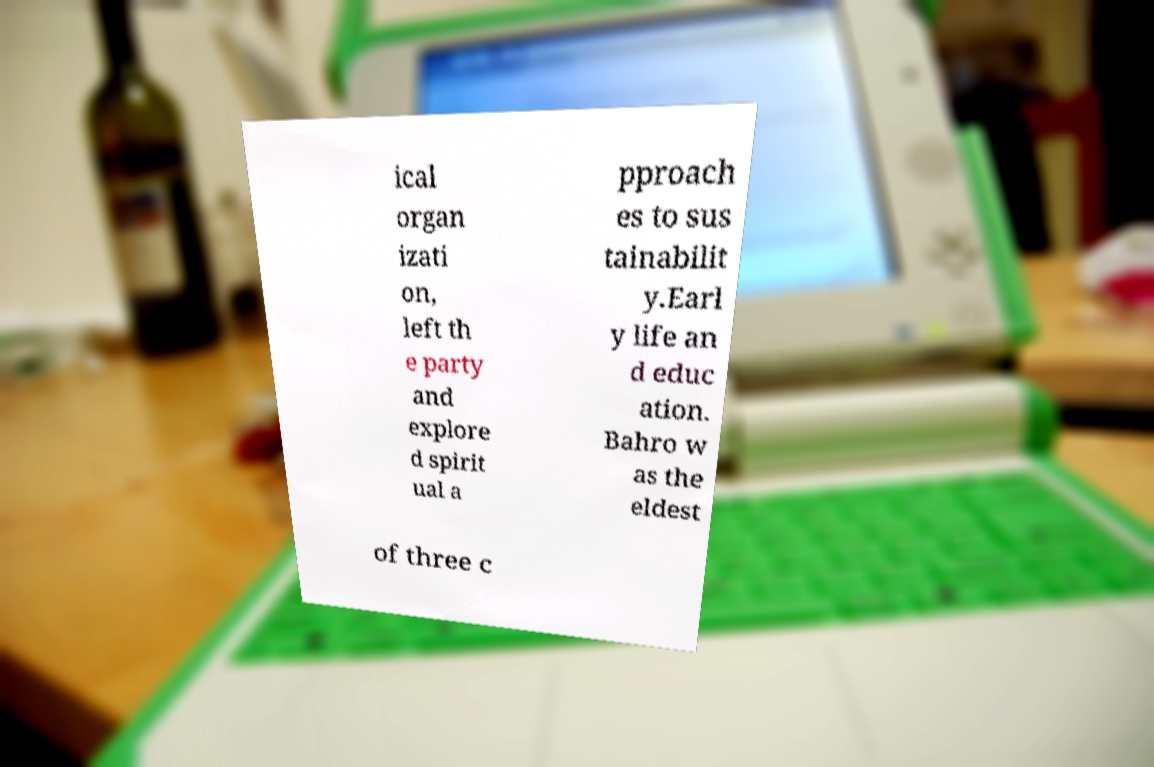There's text embedded in this image that I need extracted. Can you transcribe it verbatim? ical organ izati on, left th e party and explore d spirit ual a pproach es to sus tainabilit y.Earl y life an d educ ation. Bahro w as the eldest of three c 